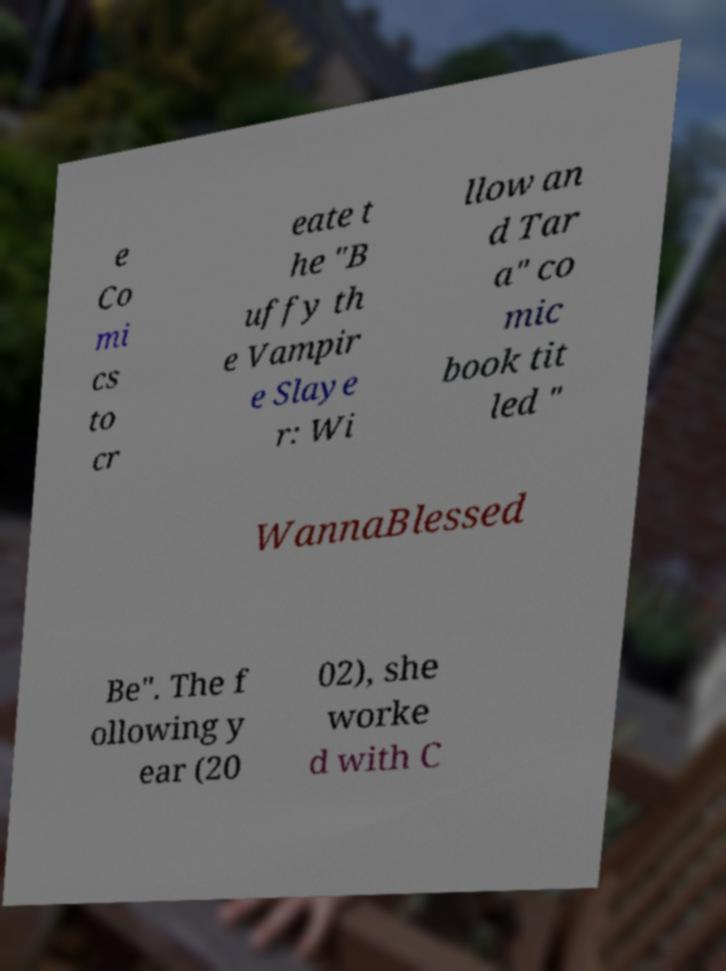There's text embedded in this image that I need extracted. Can you transcribe it verbatim? e Co mi cs to cr eate t he "B uffy th e Vampir e Slaye r: Wi llow an d Tar a" co mic book tit led " WannaBlessed Be". The f ollowing y ear (20 02), she worke d with C 